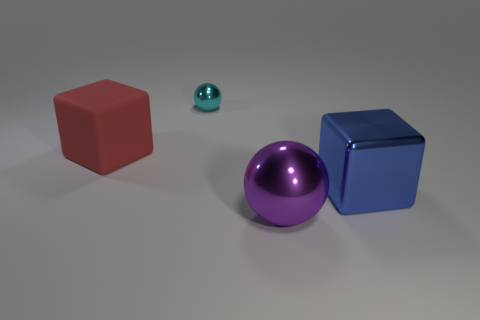Add 4 tiny yellow rubber cylinders. How many objects exist? 8 Add 3 small cyan objects. How many small cyan objects exist? 4 Subtract 0 purple cylinders. How many objects are left? 4 Subtract all small cyan things. Subtract all small cyan spheres. How many objects are left? 2 Add 2 rubber cubes. How many rubber cubes are left? 3 